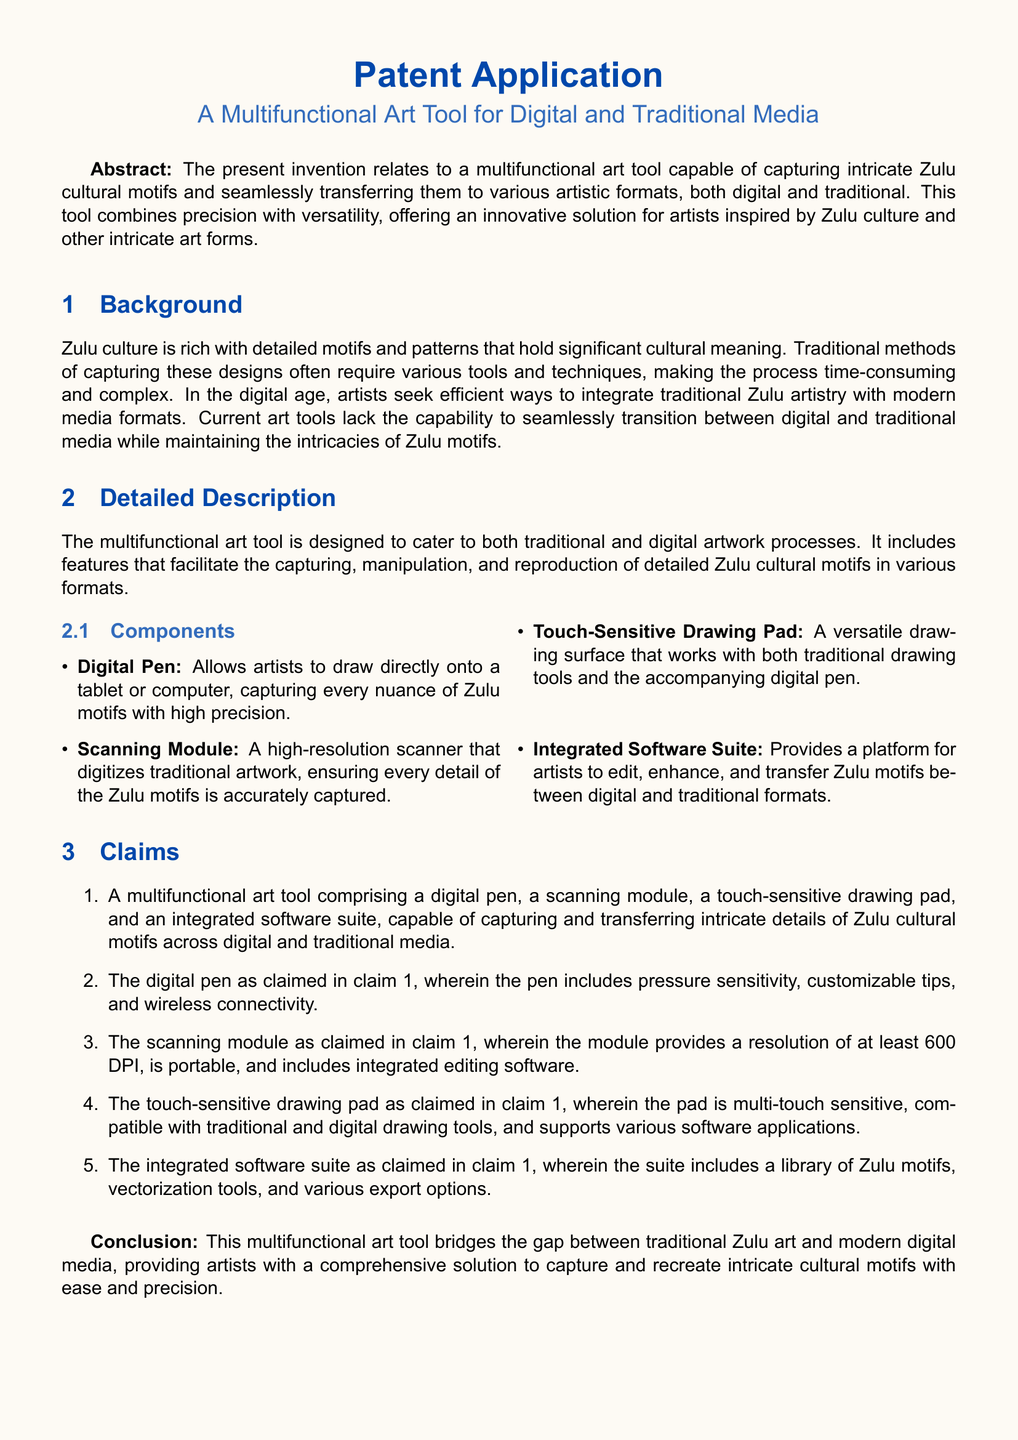What is the invention related to? The invention relates to a multifunctional art tool designed for capturing intricate Zulu cultural motifs and transferring them to various artistic formats.
Answer: multifunctional art tool What components are included in the multifunctional art tool? The tool includes a digital pen, a scanning module, a touch-sensitive drawing pad, and an integrated software suite.
Answer: digital pen, scanning module, touch-sensitive drawing pad, integrated software suite What resolution does the scanning module provide? The scanning module provides a resolution of at least 600 DPI.
Answer: 600 DPI What is the main cultural focus of the art tool? The main cultural focus of the art tool is Zulu culture and its intricate motifs.
Answer: Zulu culture Which feature allows artists to draw directly onto a tablet? The digital pen is the feature that allows artists to draw directly onto a tablet or computer.
Answer: digital pen What does the integrated software suite include? The integrated software suite includes a library of Zulu motifs, vectorization tools, and various export options.
Answer: library of Zulu motifs, vectorization tools, and various export options What problem does the multifunctional art tool address? It addresses the complexity and time consumption in capturing traditional Zulu motifs using current art tools.
Answer: complexity and time consumption What type of document is this? This is a patent application.
Answer: patent application 